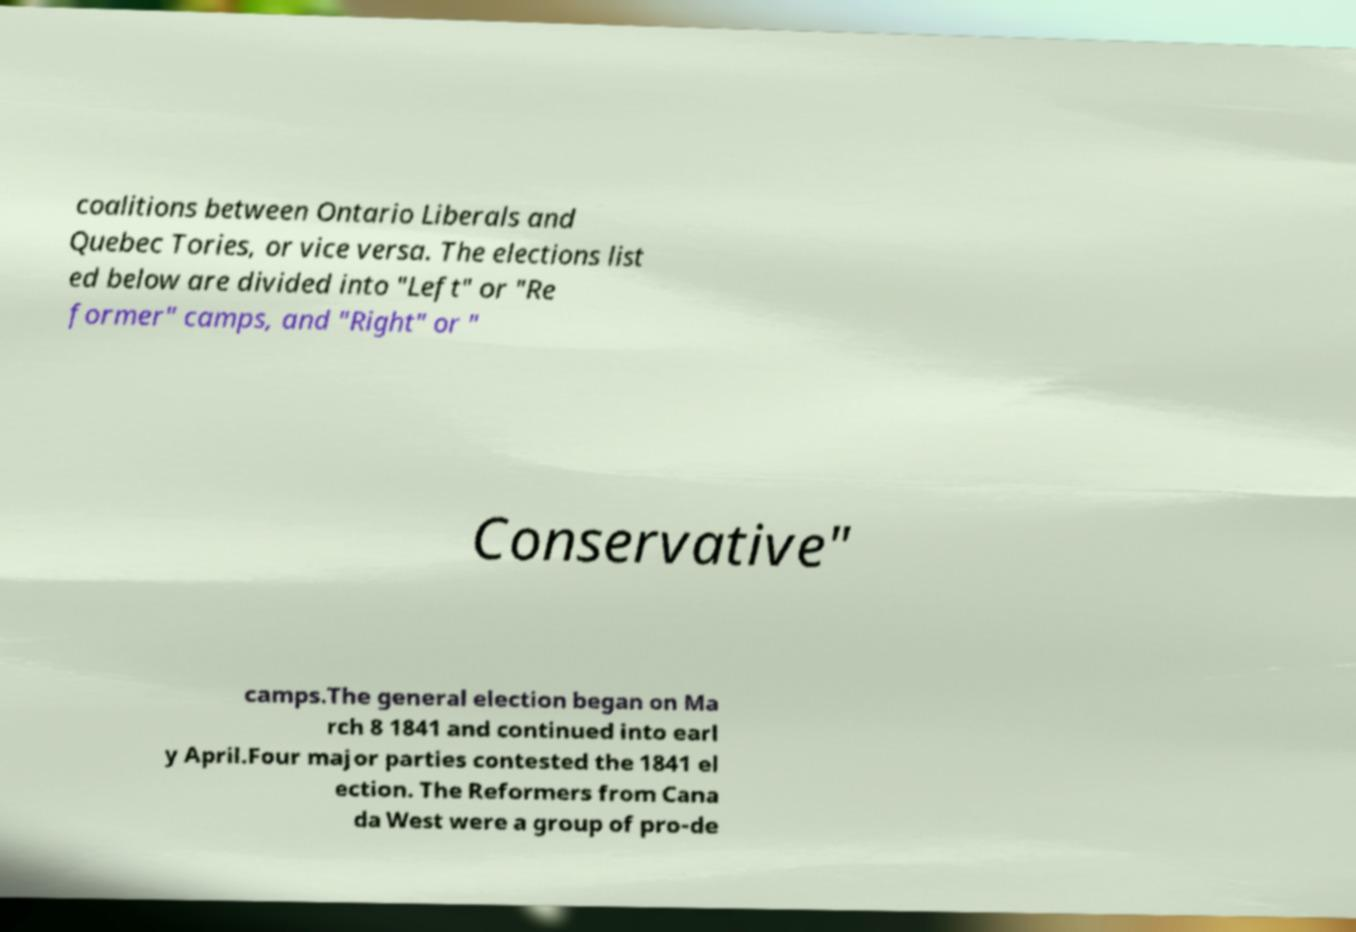I need the written content from this picture converted into text. Can you do that? coalitions between Ontario Liberals and Quebec Tories, or vice versa. The elections list ed below are divided into "Left" or "Re former" camps, and "Right" or " Conservative" camps.The general election began on Ma rch 8 1841 and continued into earl y April.Four major parties contested the 1841 el ection. The Reformers from Cana da West were a group of pro-de 